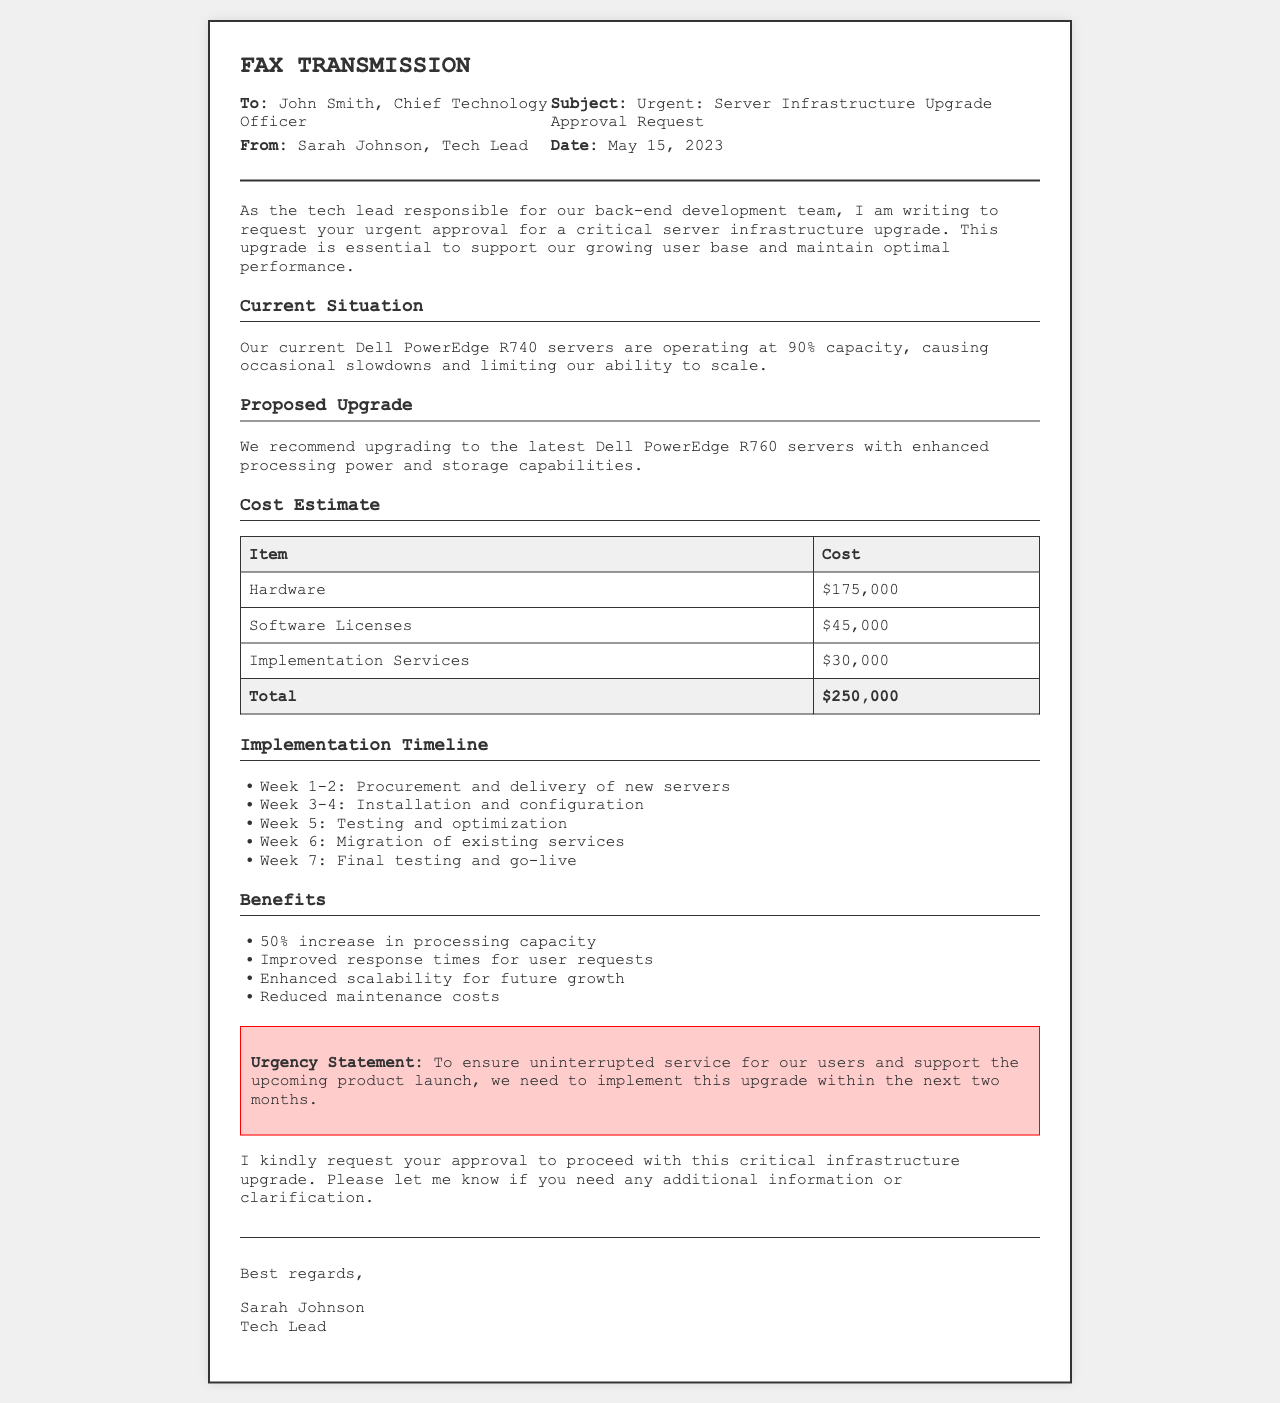What is the name of the sender? The sender of the fax is Sarah Johnson, as stated in the header.
Answer: Sarah Johnson What is the cost of hardware? The cost of hardware is listed in the cost estimate section of the document.
Answer: $175,000 What is the total cost of the upgrade? The total cost is summarized in the last row of the cost table.
Answer: $250,000 How many weeks is planned for the testing phase? The testing phase is mentioned as being planned for Week 5 in the implementation timeline.
Answer: 1 What is the benefit of reduced maintenance costs? Reduced maintenance costs contribute to overall cost efficiency, but a concise answer focuses on the stated benefits.
Answer: Cost Efficiency What is the urgency statement about? The urgency statement emphasizes the need for the upgrade within the next two months to ensure uninterrupted service.
Answer: Uninterrupted service What type of servers are currently in use? The document specifies that the current servers are Dell PowerEdge R740.
Answer: Dell PowerEdge R740 How many items are listed in the cost estimate? There are three specific cost items mentioned before the total row in the cost table.
Answer: 3 Who is the recipient of the fax? The recipient is named in the header section of the document.
Answer: John Smith 